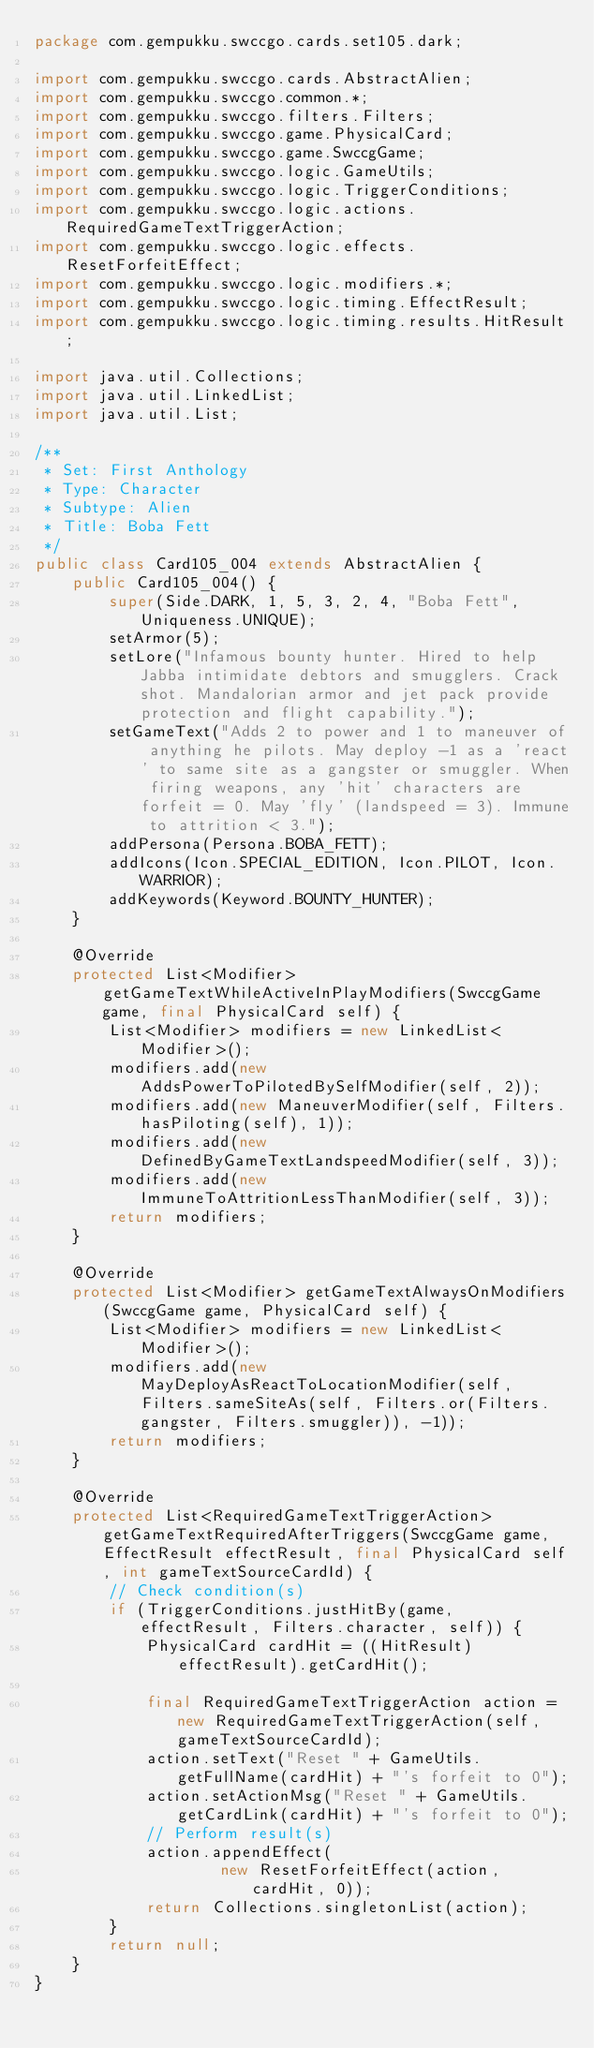<code> <loc_0><loc_0><loc_500><loc_500><_Java_>package com.gempukku.swccgo.cards.set105.dark;

import com.gempukku.swccgo.cards.AbstractAlien;
import com.gempukku.swccgo.common.*;
import com.gempukku.swccgo.filters.Filters;
import com.gempukku.swccgo.game.PhysicalCard;
import com.gempukku.swccgo.game.SwccgGame;
import com.gempukku.swccgo.logic.GameUtils;
import com.gempukku.swccgo.logic.TriggerConditions;
import com.gempukku.swccgo.logic.actions.RequiredGameTextTriggerAction;
import com.gempukku.swccgo.logic.effects.ResetForfeitEffect;
import com.gempukku.swccgo.logic.modifiers.*;
import com.gempukku.swccgo.logic.timing.EffectResult;
import com.gempukku.swccgo.logic.timing.results.HitResult;

import java.util.Collections;
import java.util.LinkedList;
import java.util.List;

/**
 * Set: First Anthology
 * Type: Character
 * Subtype: Alien
 * Title: Boba Fett
 */
public class Card105_004 extends AbstractAlien {
    public Card105_004() {
        super(Side.DARK, 1, 5, 3, 2, 4, "Boba Fett", Uniqueness.UNIQUE);
        setArmor(5);
        setLore("Infamous bounty hunter. Hired to help Jabba intimidate debtors and smugglers. Crack shot. Mandalorian armor and jet pack provide protection and flight capability.");
        setGameText("Adds 2 to power and 1 to maneuver of anything he pilots. May deploy -1 as a 'react' to same site as a gangster or smuggler. When firing weapons, any 'hit' characters are forfeit = 0. May 'fly' (landspeed = 3). Immune to attrition < 3.");
        addPersona(Persona.BOBA_FETT);
        addIcons(Icon.SPECIAL_EDITION, Icon.PILOT, Icon.WARRIOR);
        addKeywords(Keyword.BOUNTY_HUNTER);
    }

    @Override
    protected List<Modifier> getGameTextWhileActiveInPlayModifiers(SwccgGame game, final PhysicalCard self) {
        List<Modifier> modifiers = new LinkedList<Modifier>();
        modifiers.add(new AddsPowerToPilotedBySelfModifier(self, 2));
        modifiers.add(new ManeuverModifier(self, Filters.hasPiloting(self), 1));
        modifiers.add(new DefinedByGameTextLandspeedModifier(self, 3));
        modifiers.add(new ImmuneToAttritionLessThanModifier(self, 3));
        return modifiers;
    }

    @Override
    protected List<Modifier> getGameTextAlwaysOnModifiers(SwccgGame game, PhysicalCard self) {
        List<Modifier> modifiers = new LinkedList<Modifier>();
        modifiers.add(new MayDeployAsReactToLocationModifier(self, Filters.sameSiteAs(self, Filters.or(Filters.gangster, Filters.smuggler)), -1));
        return modifiers;
    }

    @Override
    protected List<RequiredGameTextTriggerAction> getGameTextRequiredAfterTriggers(SwccgGame game, EffectResult effectResult, final PhysicalCard self, int gameTextSourceCardId) {
        // Check condition(s)
        if (TriggerConditions.justHitBy(game, effectResult, Filters.character, self)) {
            PhysicalCard cardHit = ((HitResult) effectResult).getCardHit();

            final RequiredGameTextTriggerAction action = new RequiredGameTextTriggerAction(self, gameTextSourceCardId);
            action.setText("Reset " + GameUtils.getFullName(cardHit) + "'s forfeit to 0");
            action.setActionMsg("Reset " + GameUtils.getCardLink(cardHit) + "'s forfeit to 0");
            // Perform result(s)
            action.appendEffect(
                    new ResetForfeitEffect(action, cardHit, 0));
            return Collections.singletonList(action);
        }
        return null;
    }
}
</code> 